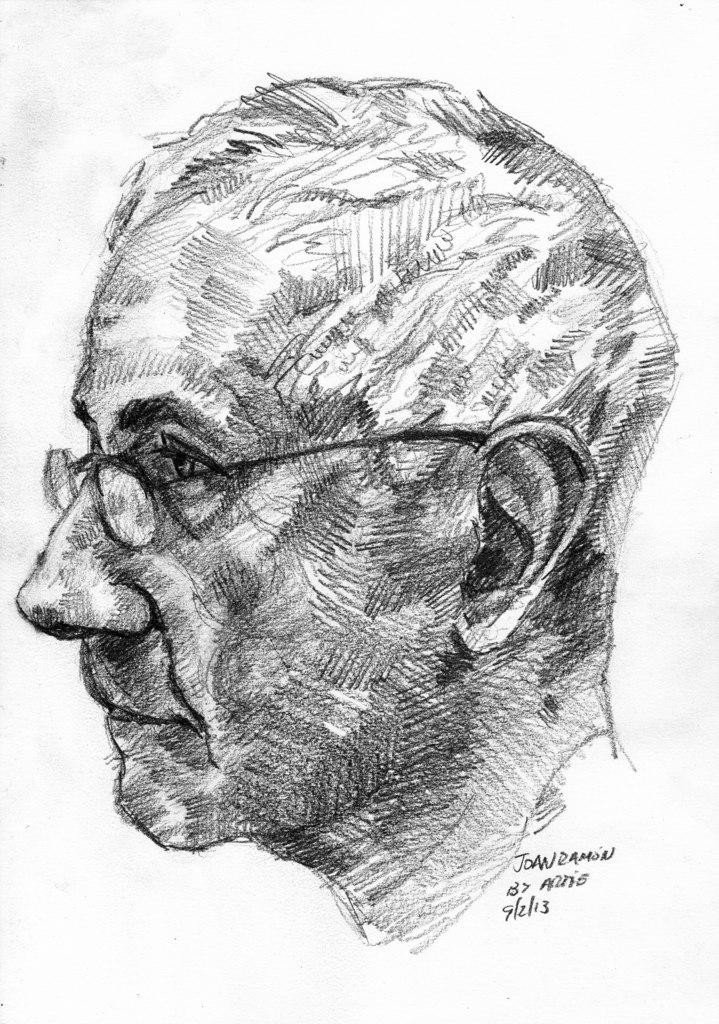What is the main subject of the image? The main subject of the image is an art piece on a paper. Can you describe the art piece in the image? Unfortunately, the image does not provide enough detail to describe the art piece. Is there any furniture or objects visible in the image? No, the image only shows an art piece on a paper. Can you tell me how many snails are crawling on the desk in the image? There is no desk or snails present in the image; it only features an art piece on a paper. 